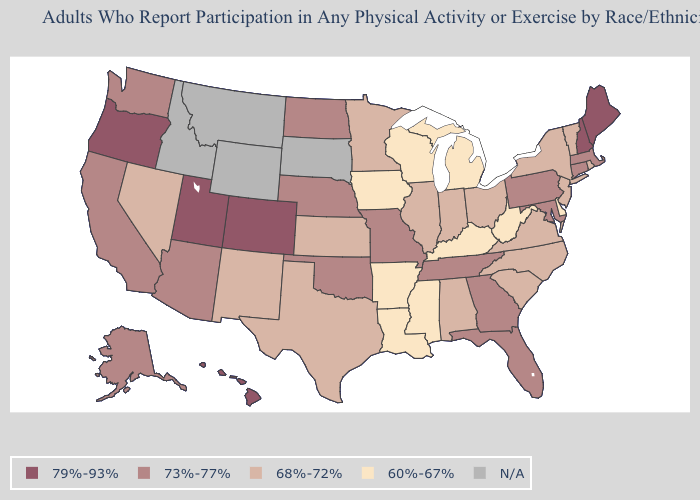How many symbols are there in the legend?
Answer briefly. 5. What is the lowest value in the Northeast?
Be succinct. 68%-72%. Name the states that have a value in the range 60%-67%?
Be succinct. Arkansas, Delaware, Iowa, Kentucky, Louisiana, Michigan, Mississippi, West Virginia, Wisconsin. How many symbols are there in the legend?
Write a very short answer. 5. Name the states that have a value in the range 79%-93%?
Answer briefly. Colorado, Hawaii, Maine, New Hampshire, Oregon, Utah. What is the value of Alaska?
Be succinct. 73%-77%. Does Hawaii have the highest value in the USA?
Answer briefly. Yes. Name the states that have a value in the range 60%-67%?
Short answer required. Arkansas, Delaware, Iowa, Kentucky, Louisiana, Michigan, Mississippi, West Virginia, Wisconsin. How many symbols are there in the legend?
Keep it brief. 5. What is the highest value in the USA?
Quick response, please. 79%-93%. Among the states that border Connecticut , does Massachusetts have the highest value?
Give a very brief answer. Yes. What is the value of North Carolina?
Short answer required. 68%-72%. What is the lowest value in states that border Nebraska?
Keep it brief. 60%-67%. Does Connecticut have the highest value in the USA?
Write a very short answer. No. Name the states that have a value in the range 79%-93%?
Short answer required. Colorado, Hawaii, Maine, New Hampshire, Oregon, Utah. 